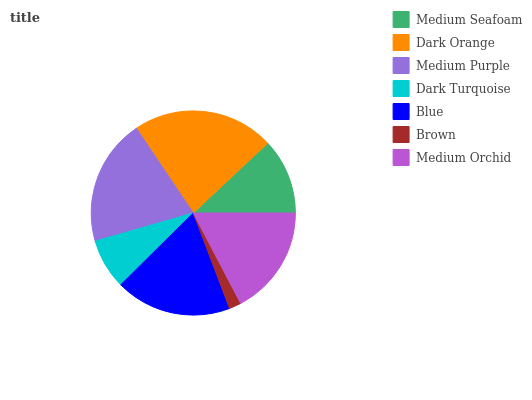Is Brown the minimum?
Answer yes or no. Yes. Is Dark Orange the maximum?
Answer yes or no. Yes. Is Medium Purple the minimum?
Answer yes or no. No. Is Medium Purple the maximum?
Answer yes or no. No. Is Dark Orange greater than Medium Purple?
Answer yes or no. Yes. Is Medium Purple less than Dark Orange?
Answer yes or no. Yes. Is Medium Purple greater than Dark Orange?
Answer yes or no. No. Is Dark Orange less than Medium Purple?
Answer yes or no. No. Is Medium Orchid the high median?
Answer yes or no. Yes. Is Medium Orchid the low median?
Answer yes or no. Yes. Is Medium Purple the high median?
Answer yes or no. No. Is Medium Purple the low median?
Answer yes or no. No. 